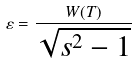<formula> <loc_0><loc_0><loc_500><loc_500>\varepsilon = \frac { W ( T ) } { \sqrt { s ^ { 2 } - 1 } }</formula> 